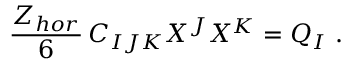Convert formula to latex. <formula><loc_0><loc_0><loc_500><loc_500>{ \frac { Z _ { h o r } } { 6 } } \, C _ { I J K } X ^ { J } X ^ { K } = Q _ { I } \ .</formula> 